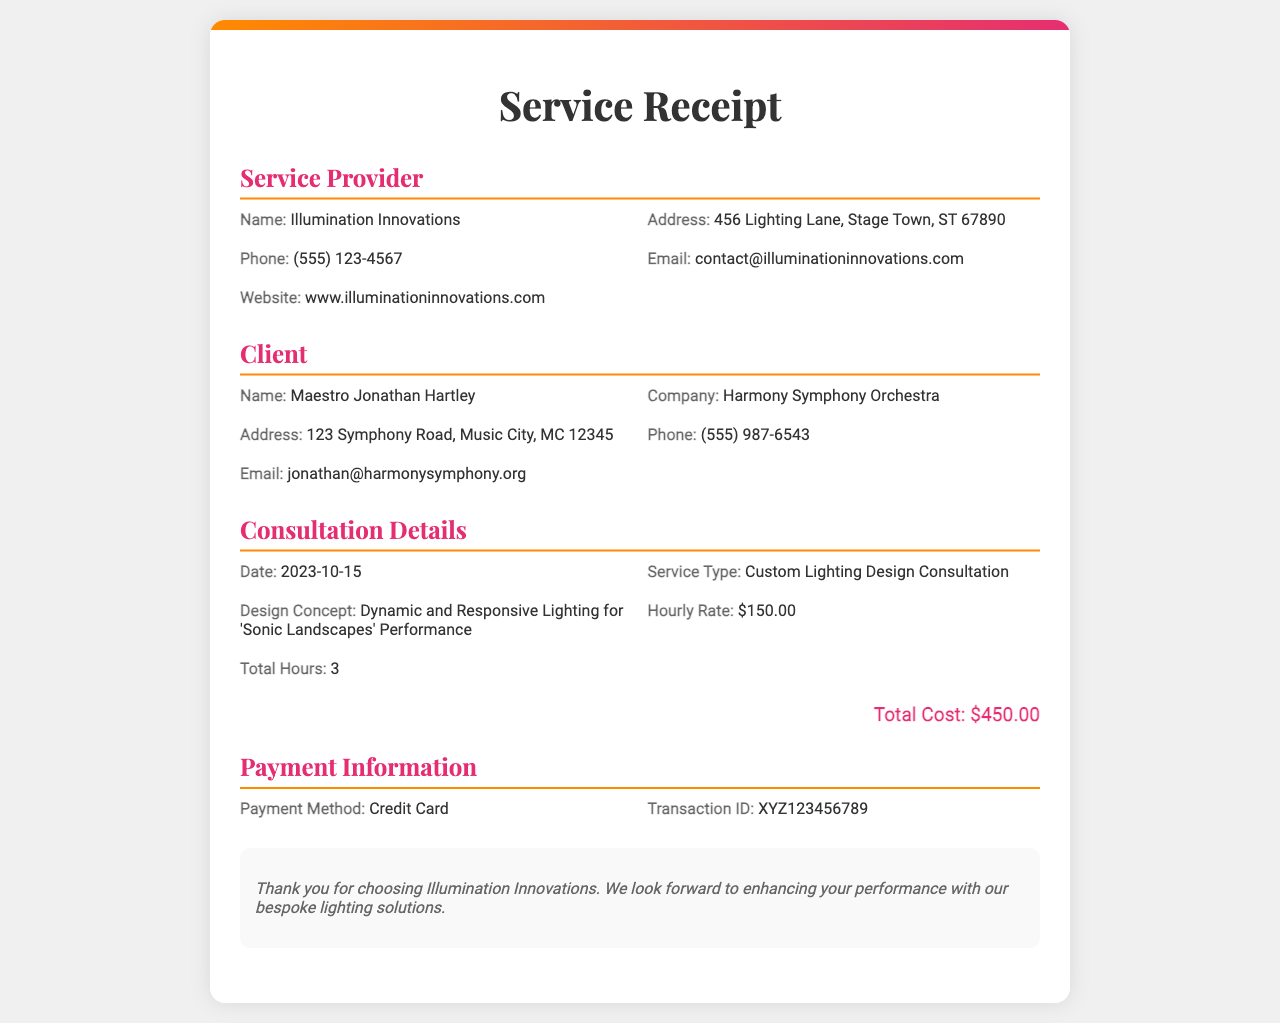what is the service type? The service type is specified under the consultation details section of the document.
Answer: Custom Lighting Design Consultation who is the service provider? The service provider's name is stated in the service provider section of the document.
Answer: Illumination Innovations what is the hourly rate? The hourly rate is mentioned in the consultation details section.
Answer: $150.00 how many total consultation hours were billed? Total consultation hours are listed under the consultation details section.
Answer: 3 what is the total cost? The total cost is calculated and stated at the end of the consultation details section.
Answer: $450.00 who is the client? The client's name is provided in the client section of the document.
Answer: Maestro Jonathan Hartley what payment method was used? The payment method can be found in the payment information section.
Answer: Credit Card what is the design concept for the consultation? The design concept is detailed under the consultation details section.
Answer: Dynamic and Responsive Lighting for 'Sonic Landscapes' Performance what is the date of the consultation? The date of the consultation is provided in the consultation details.
Answer: 2023-10-15 